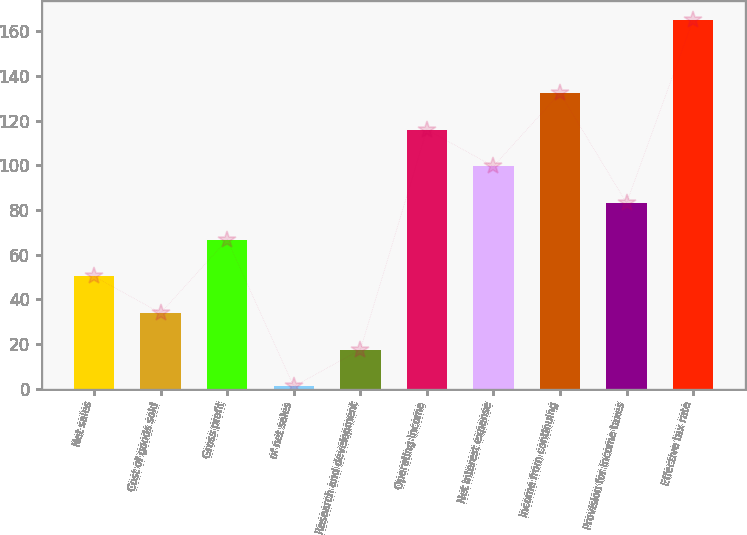Convert chart to OTSL. <chart><loc_0><loc_0><loc_500><loc_500><bar_chart><fcel>Net sales<fcel>Cost of goods sold<fcel>Gross profit<fcel>of net sales<fcel>Research and development<fcel>Operating income<fcel>Net interest expense<fcel>Income from continuing<fcel>Provision for income taxes<fcel>Effective tax rate<nl><fcel>50.3<fcel>33.9<fcel>66.7<fcel>1.1<fcel>17.5<fcel>115.9<fcel>99.5<fcel>132.3<fcel>83.1<fcel>165.1<nl></chart> 